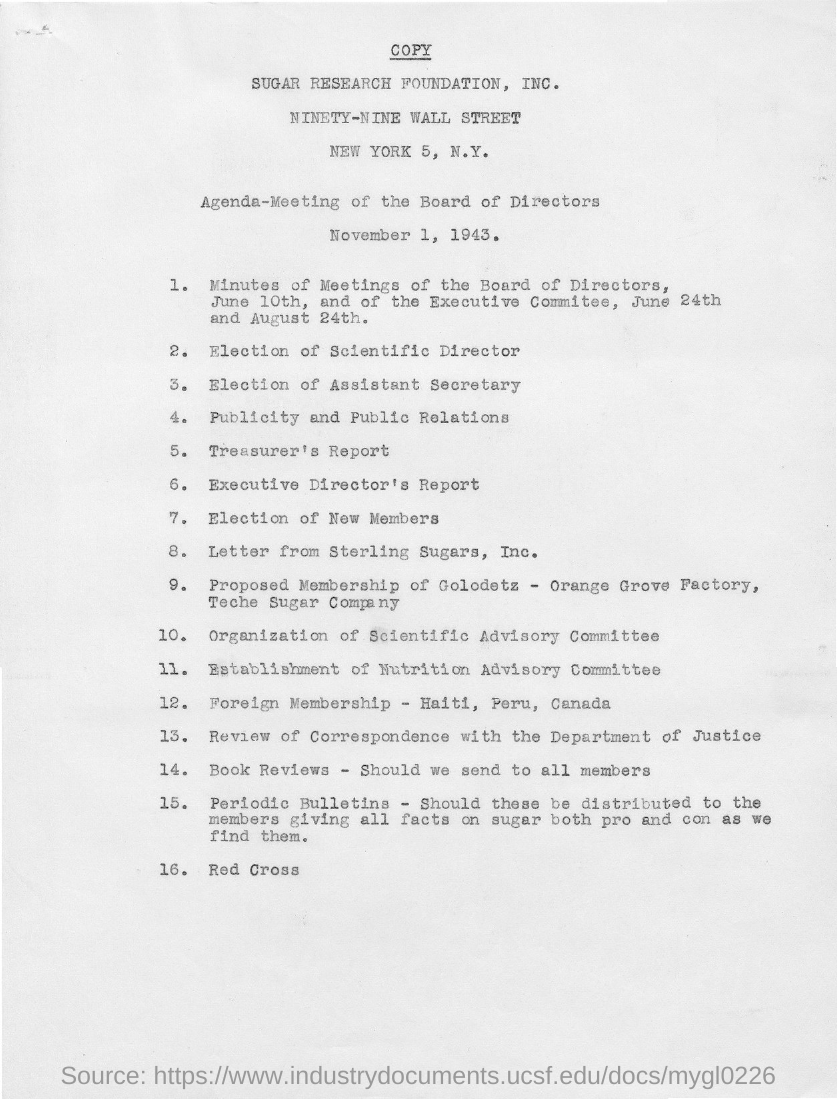What is the meeting date?
Make the answer very short. November 1, 1943. It is the agenda for what?
Keep it short and to the point. Meeting of the board of directors. What is the second agenda?
Ensure brevity in your answer.  Election of scientific director. What is the last agenda?
Offer a terse response. Red cross. How many agendas are there for the meeting?
Offer a very short reply. 16. 